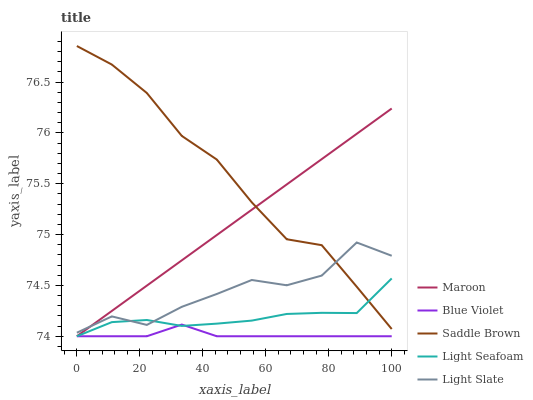Does Blue Violet have the minimum area under the curve?
Answer yes or no. Yes. Does Saddle Brown have the maximum area under the curve?
Answer yes or no. Yes. Does Light Seafoam have the minimum area under the curve?
Answer yes or no. No. Does Light Seafoam have the maximum area under the curve?
Answer yes or no. No. Is Maroon the smoothest?
Answer yes or no. Yes. Is Light Slate the roughest?
Answer yes or no. Yes. Is Light Seafoam the smoothest?
Answer yes or no. No. Is Light Seafoam the roughest?
Answer yes or no. No. Does Light Seafoam have the lowest value?
Answer yes or no. Yes. Does Saddle Brown have the lowest value?
Answer yes or no. No. Does Saddle Brown have the highest value?
Answer yes or no. Yes. Does Light Seafoam have the highest value?
Answer yes or no. No. Is Blue Violet less than Light Slate?
Answer yes or no. Yes. Is Saddle Brown greater than Blue Violet?
Answer yes or no. Yes. Does Light Seafoam intersect Blue Violet?
Answer yes or no. Yes. Is Light Seafoam less than Blue Violet?
Answer yes or no. No. Is Light Seafoam greater than Blue Violet?
Answer yes or no. No. Does Blue Violet intersect Light Slate?
Answer yes or no. No. 